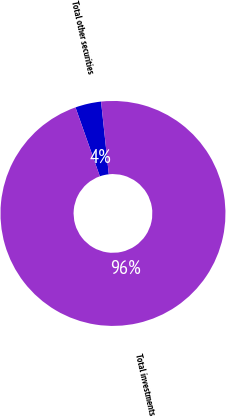<chart> <loc_0><loc_0><loc_500><loc_500><pie_chart><fcel>Total other securities<fcel>Total investments<nl><fcel>3.72%<fcel>96.28%<nl></chart> 